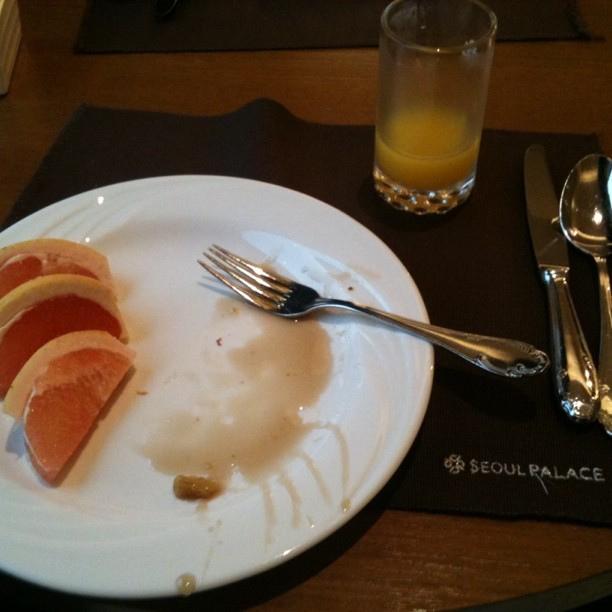What is on the plate?
Short answer required. Fork and fruit. How many forks are there?
Be succinct. 1. What is the food item to the left?
Write a very short answer. Orange. Is there cause for celebration?
Concise answer only. No. Did someone use a plastic spoon to eat?
Keep it brief. No. How much fluid does the class hold with the beer in it?
Quick response, please. Little. What are the crumbs on the plate?
Quick response, please. Pancake. Are there any vegetables?
Answer briefly. No. What type of knife is shown?
Quick response, please. Butter. Is this food sweet?
Short answer required. Yes. What shape is the plate?
Be succinct. Circle. Is the knife soiled?
Quick response, please. No. What utensil is on the plate?
Concise answer only. Fork. How many utensils are visible?
Concise answer only. 3. What is the swirl on the plate?
Keep it brief. Juice. Is this fork clean?
Write a very short answer. No. What restaurant is this at?
Give a very brief answer. Seoul palace. What liquid is in the glass?
Write a very short answer. Orange juice. How many holes are in the spoon?
Be succinct. 0. What kind of food is this?
Write a very short answer. Fruit. What type of utensil is in the bowl?
Short answer required. Fork. What dipping tool is being used?
Short answer required. Fork. How many desserts are on the table?
Answer briefly. 1. What has been eaten?
Write a very short answer. Pancakes. What is in the cup?
Answer briefly. Orange juice. What color is the handle of the fork?
Give a very brief answer. Silver. 